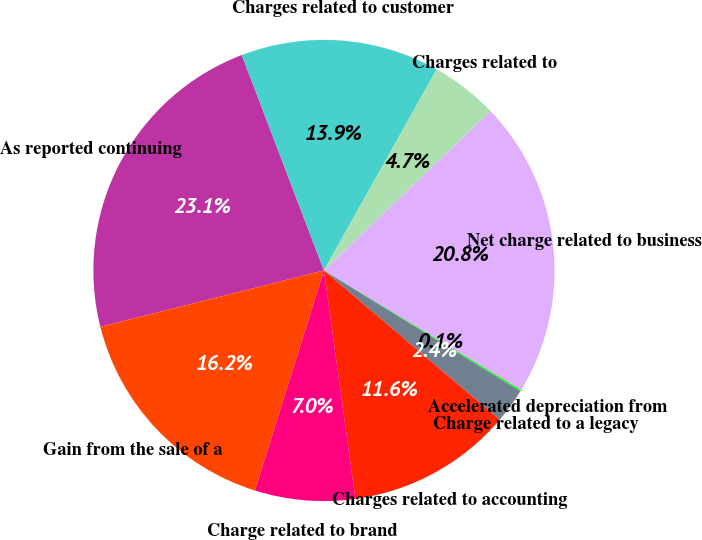Convert chart to OTSL. <chart><loc_0><loc_0><loc_500><loc_500><pie_chart><fcel>As reported continuing<fcel>Charges related to customer<fcel>Charges related to<fcel>Net charge related to business<fcel>Accelerated depreciation from<fcel>Charge related to a legacy<fcel>Charges related to accounting<fcel>Charge related to brand<fcel>Gain from the sale of a<nl><fcel>23.13%<fcel>13.93%<fcel>4.72%<fcel>20.83%<fcel>0.11%<fcel>2.41%<fcel>11.62%<fcel>7.02%<fcel>16.23%<nl></chart> 